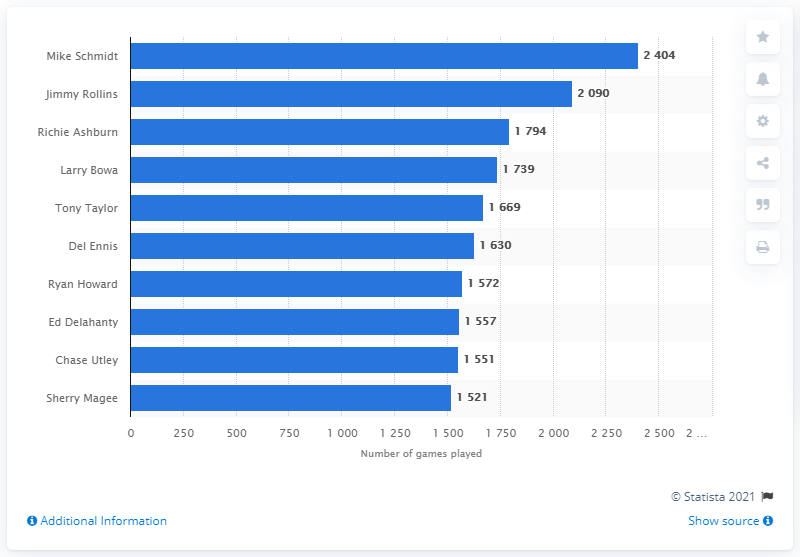Mention a couple of crucial points in this snapshot. The individual who has played the most games in the history of the Philadelphia Phillies franchise is Mike Schmidt. 